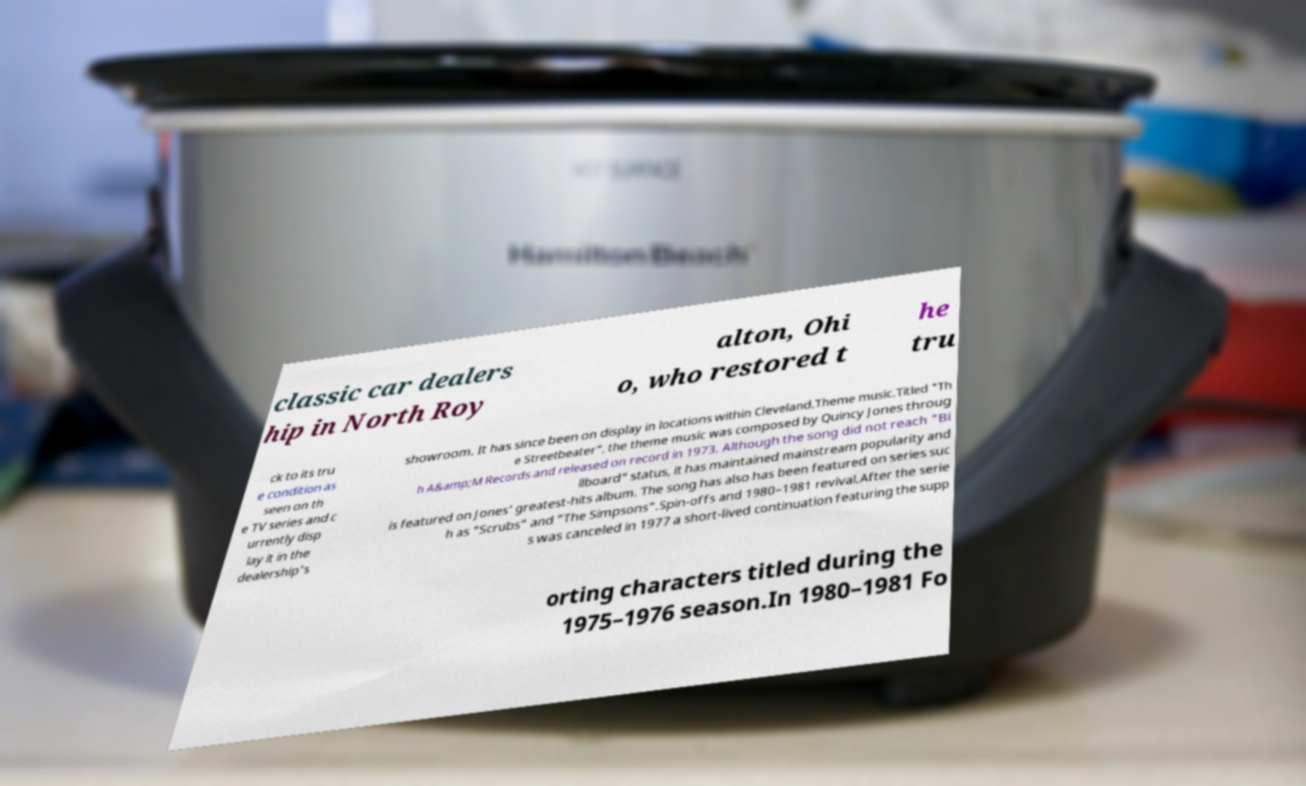I need the written content from this picture converted into text. Can you do that? classic car dealers hip in North Roy alton, Ohi o, who restored t he tru ck to its tru e condition as seen on th e TV series and c urrently disp lay it in the dealership's showroom. It has since been on display in locations within Cleveland.Theme music.Titled "Th e Streetbeater", the theme music was composed by Quincy Jones throug h A&amp;M Records and released on record in 1973. Although the song did not reach "Bi llboard" status, it has maintained mainstream popularity and is featured on Jones' greatest-hits album. The song has also has been featured on series suc h as "Scrubs" and "The Simpsons".Spin-offs and 1980–1981 revival.After the serie s was canceled in 1977 a short-lived continuation featuring the supp orting characters titled during the 1975–1976 season.In 1980–1981 Fo 